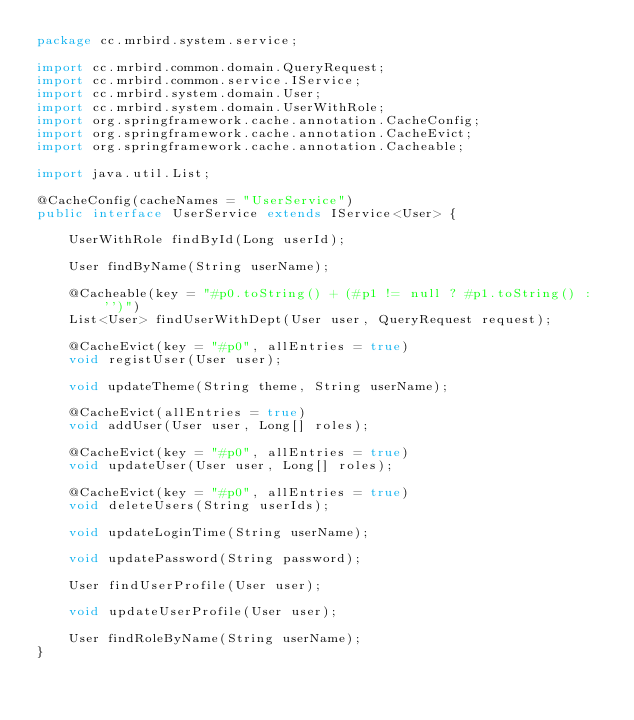Convert code to text. <code><loc_0><loc_0><loc_500><loc_500><_Java_>package cc.mrbird.system.service;

import cc.mrbird.common.domain.QueryRequest;
import cc.mrbird.common.service.IService;
import cc.mrbird.system.domain.User;
import cc.mrbird.system.domain.UserWithRole;
import org.springframework.cache.annotation.CacheConfig;
import org.springframework.cache.annotation.CacheEvict;
import org.springframework.cache.annotation.Cacheable;

import java.util.List;

@CacheConfig(cacheNames = "UserService")
public interface UserService extends IService<User> {

    UserWithRole findById(Long userId);

    User findByName(String userName);

    @Cacheable(key = "#p0.toString() + (#p1 != null ? #p1.toString() : '')")
    List<User> findUserWithDept(User user, QueryRequest request);

    @CacheEvict(key = "#p0", allEntries = true)
    void registUser(User user);

    void updateTheme(String theme, String userName);

    @CacheEvict(allEntries = true)
    void addUser(User user, Long[] roles);

    @CacheEvict(key = "#p0", allEntries = true)
    void updateUser(User user, Long[] roles);

    @CacheEvict(key = "#p0", allEntries = true)
    void deleteUsers(String userIds);

    void updateLoginTime(String userName);

    void updatePassword(String password);

    User findUserProfile(User user);

    void updateUserProfile(User user);

    User findRoleByName(String userName);
}
</code> 